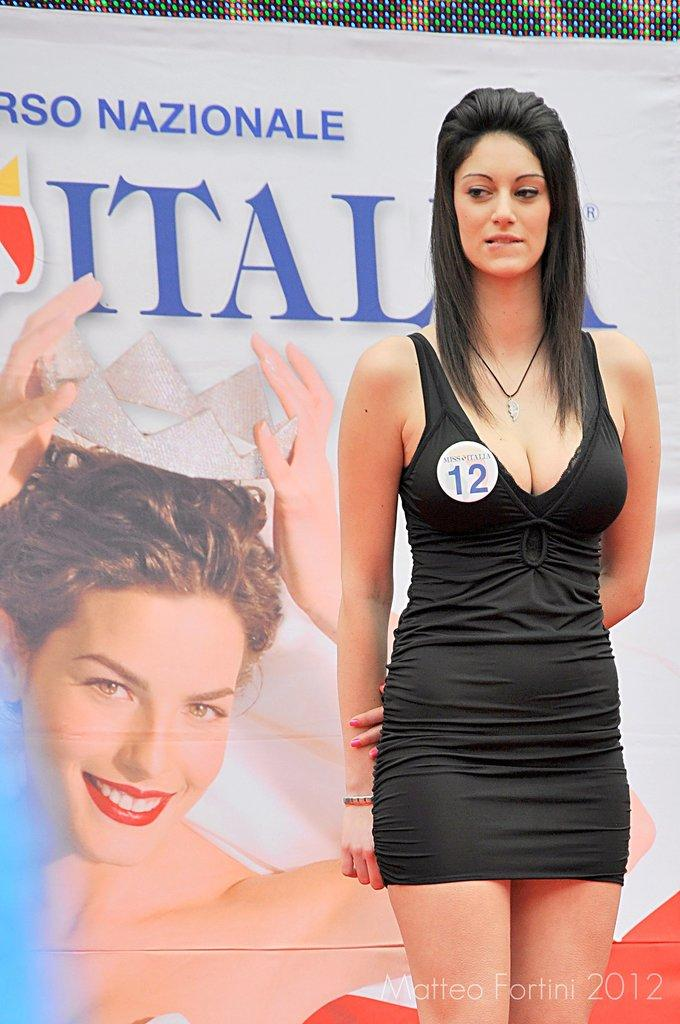Who is present in the image? There is a woman in the image. What is the woman wearing? The woman is wearing a black dress. How is the woman described in the image? The woman is stunning. What else can be seen in the image besides the woman? There is a huge banner in the image. What is depicted on the banner? Another woman holding a crown is visible on the banner. Are there any farm animals visible in the image? No, there are no farm animals present in the image. Is there a parent holding the hand of the woman in the image? No, there is no parent holding the hand of the woman in the image. 